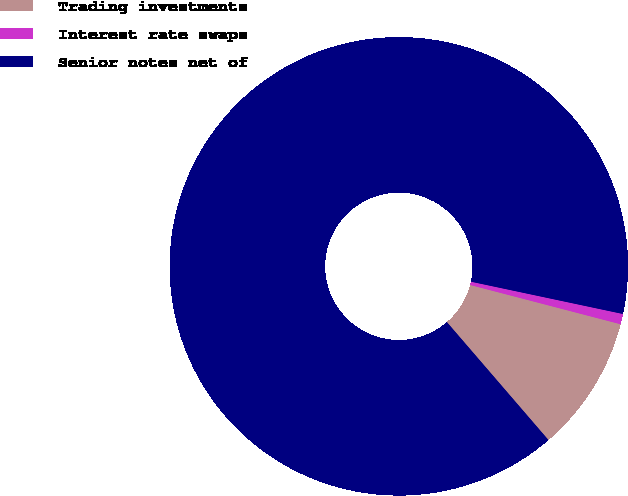Convert chart to OTSL. <chart><loc_0><loc_0><loc_500><loc_500><pie_chart><fcel>Trading investments<fcel>Interest rate swaps<fcel>Senior notes net of<nl><fcel>9.62%<fcel>0.73%<fcel>89.65%<nl></chart> 